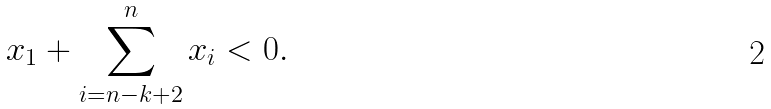<formula> <loc_0><loc_0><loc_500><loc_500>x _ { 1 } + \sum _ { i = n - k + 2 } ^ { n } x _ { i } < 0 .</formula> 